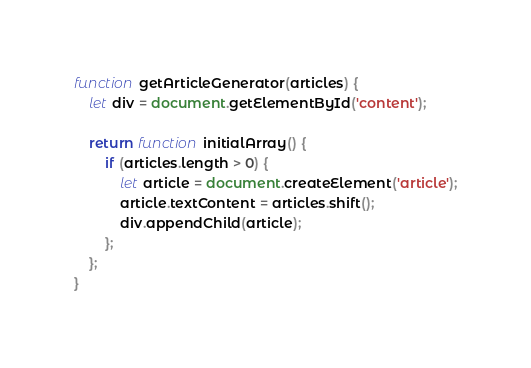Convert code to text. <code><loc_0><loc_0><loc_500><loc_500><_JavaScript_>function getArticleGenerator(articles) {
    let div = document.getElementById('content');

    return function initialArray() {
        if (articles.length > 0) {
            let article = document.createElement('article');
            article.textContent = articles.shift();
            div.appendChild(article);
        };
    };
}
</code> 